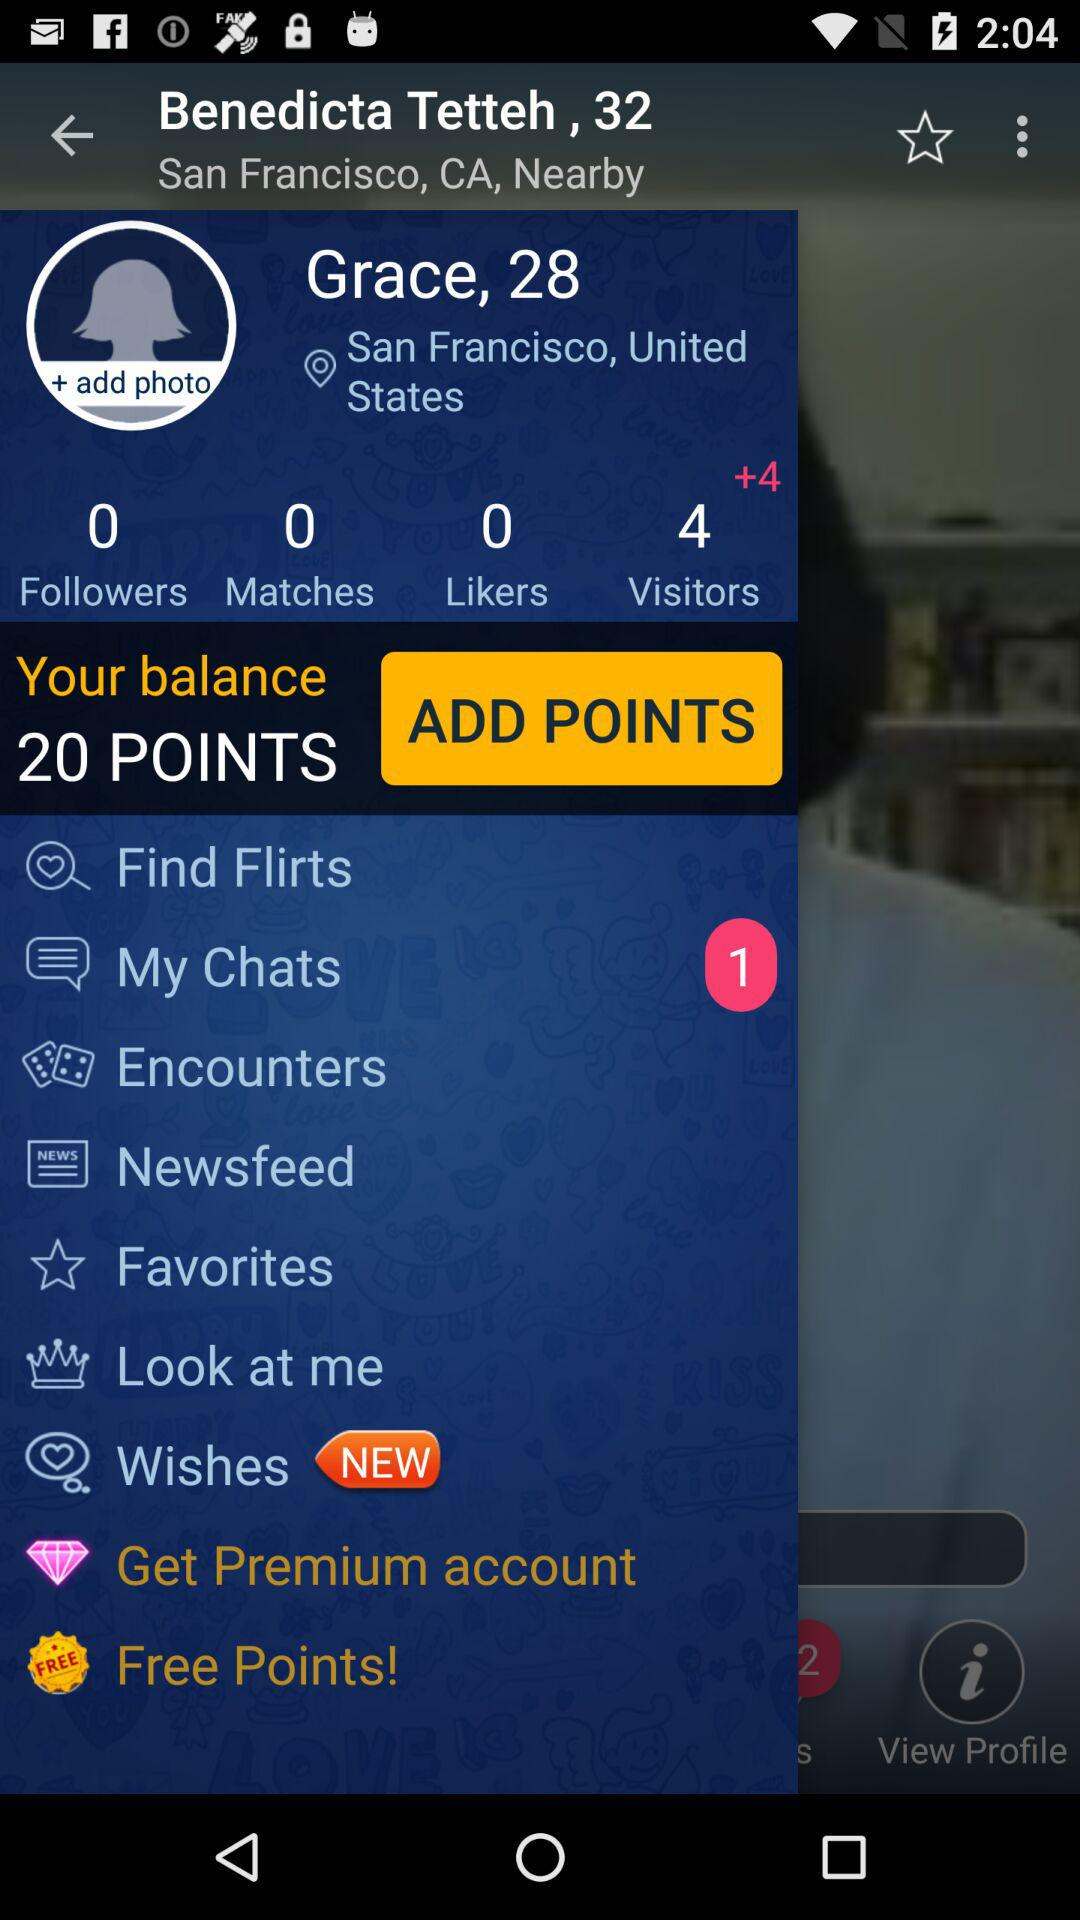What is the name of the user? The name of the user is Grace. 